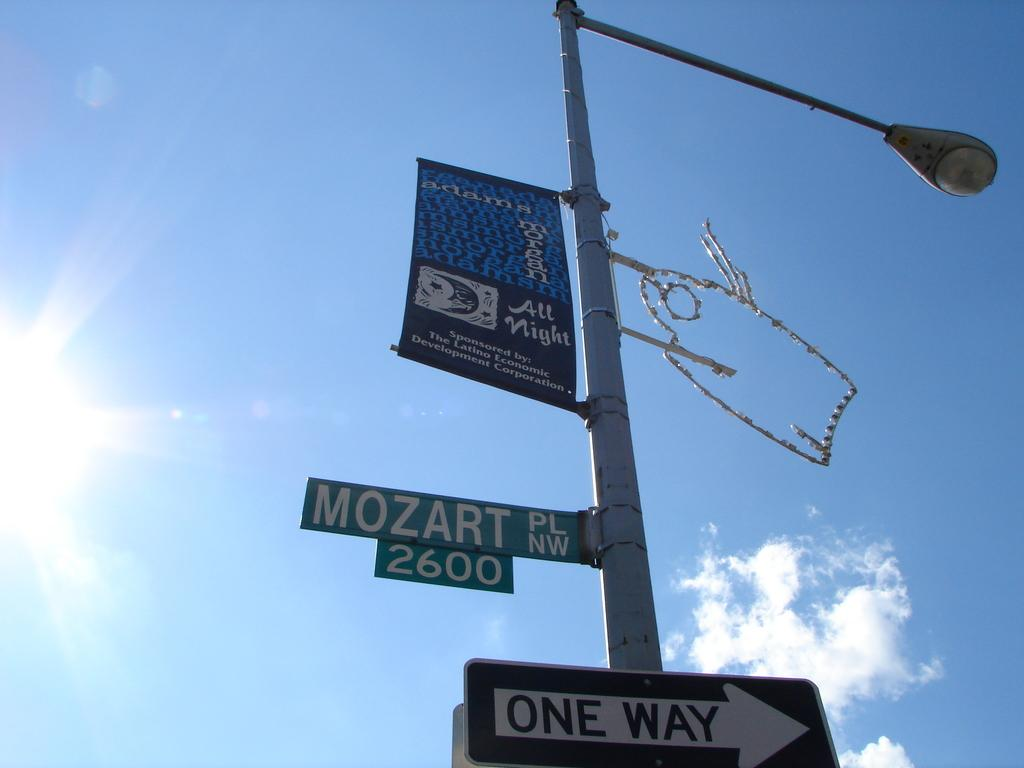<image>
Summarize the visual content of the image. A STREET LAMP WITH THE STREET SIGN "MOZART PL NW 2600" ABOVE THE ONE WAY SIGN POINTING RIGHT 